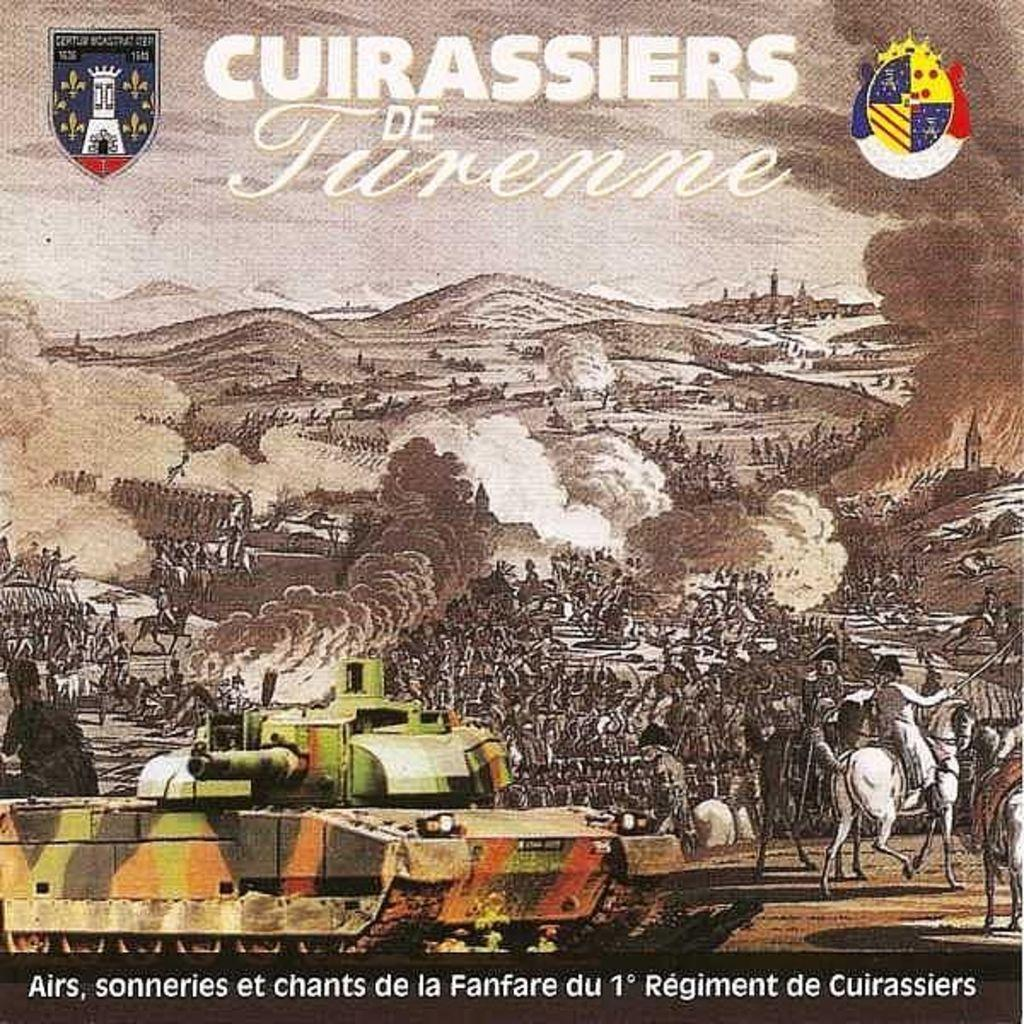What is featured on the poster in the image? The poster depicts a war scene. Are there any animals present in the image? Yes, there are horses in the image. What is the weight of the family in the image? There is no family present in the image, only a poster depicting a war scene with horses. 